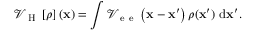<formula> <loc_0><loc_0><loc_500><loc_500>{ \mathcal { V } } _ { H } \left [ \rho \right ] \left ( { x } \right ) = \int { \mathcal { V } _ { e e } \left ( { x } - { x } ^ { \prime } \right ) \rho ( { x } ^ { \prime } ) \ d { x } ^ { \prime } } .</formula> 